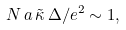<formula> <loc_0><loc_0><loc_500><loc_500>N \, a \, \tilde { \kappa } \, \Delta / e ^ { 2 } \sim 1 ,</formula> 